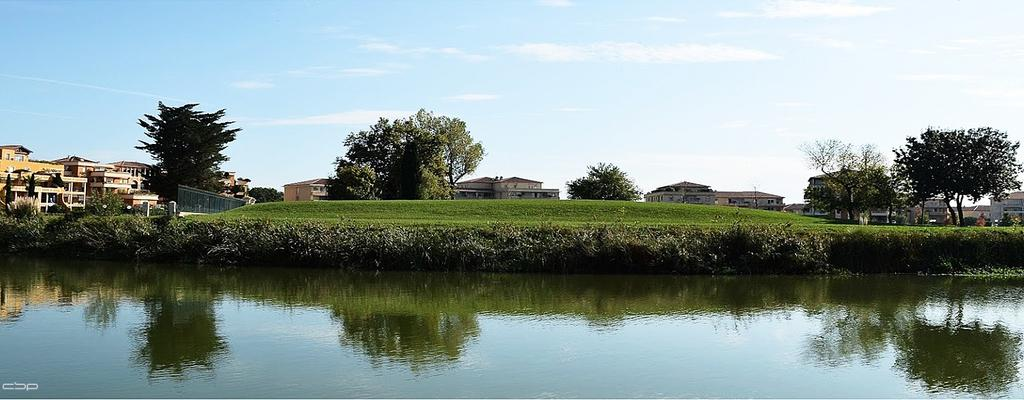What is present in the front of the image? There is water in the front of the image. What can be seen in the center of the image? There are plants in the center of the image. What type of vegetation covers the ground in the image? There is grass on the ground. What structures are visible in the background of the image? There are buildings in the background of the image. What type of vegetation is present in the background of the image? There are trees in the background of the image. How would you describe the sky in the image? The sky is cloudy in the image. How much money is being exchanged between the trees in the background of the image? There is no money exchange depicted in the image; it features water, plants, grass, buildings, trees, and a cloudy sky. What type of badge can be seen on the buildings in the background of the image? There are no badges present on the buildings in the background of the image. 